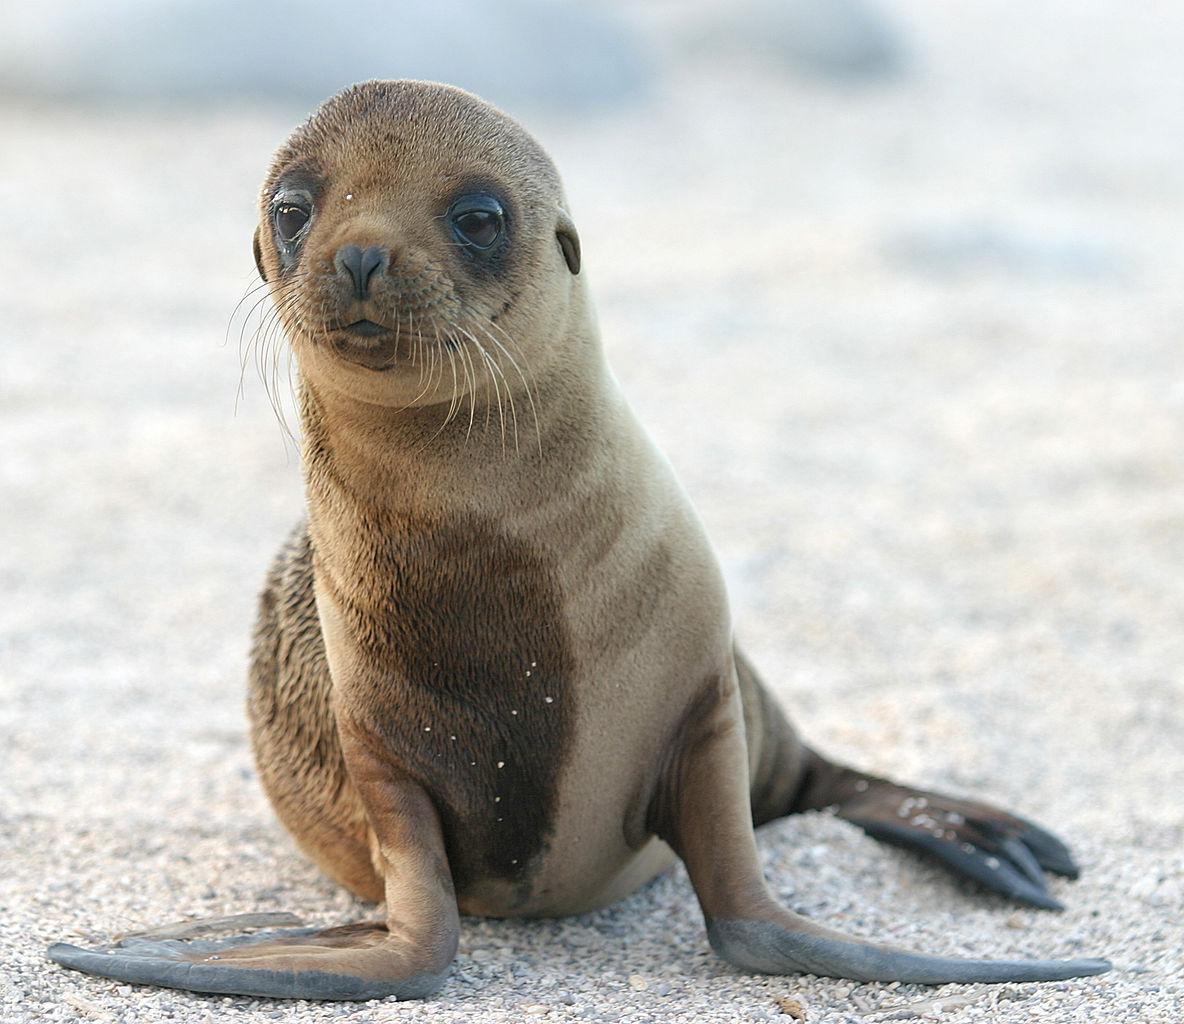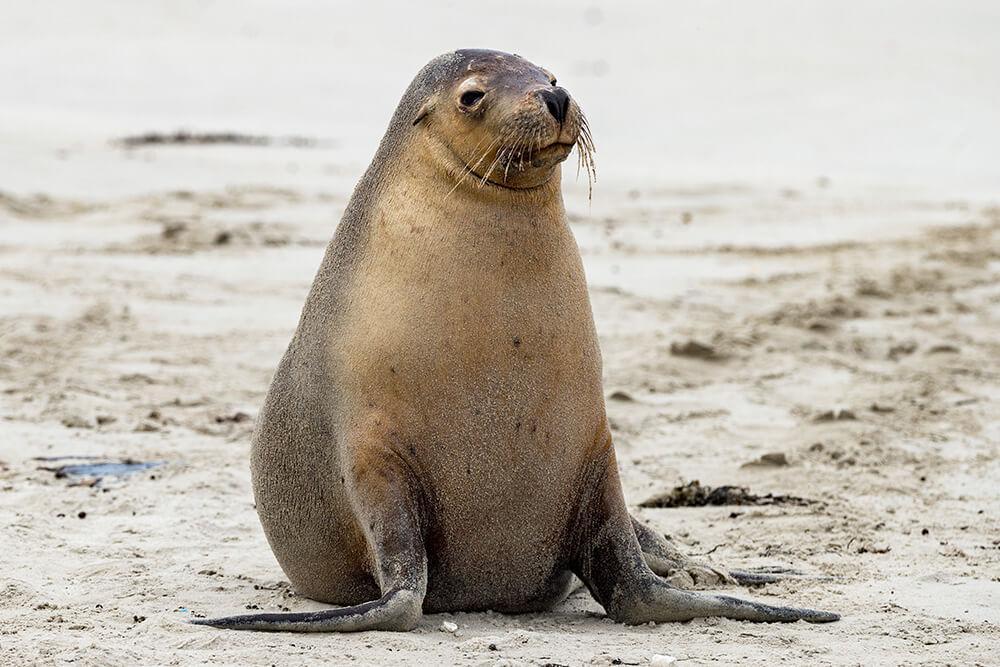The first image is the image on the left, the second image is the image on the right. Evaluate the accuracy of this statement regarding the images: "Three toes can be counted in the image on the left.". Is it true? Answer yes or no. Yes. 